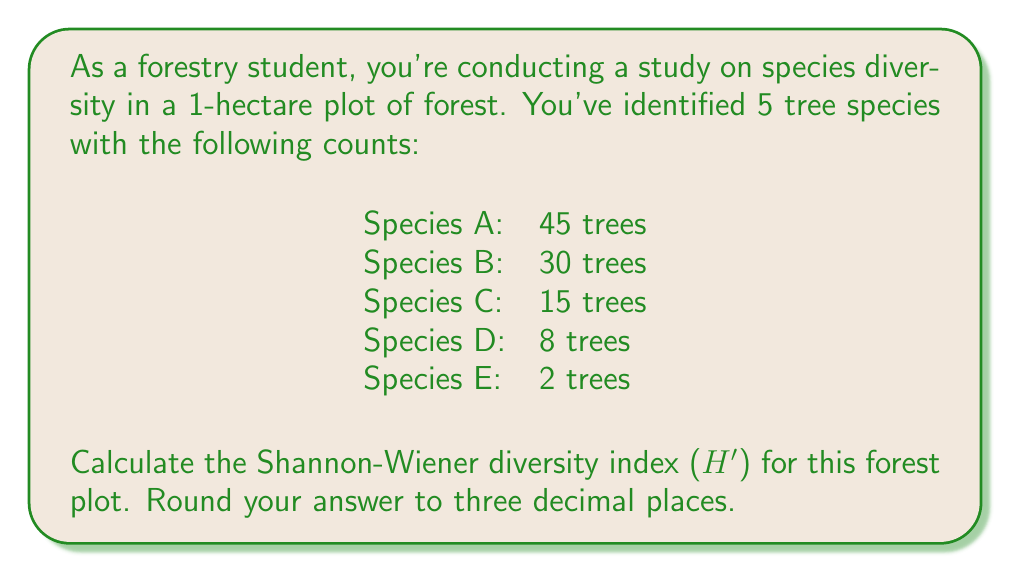Give your solution to this math problem. The Shannon-Wiener diversity index (H') is calculated using the formula:

$$ H' = -\sum_{i=1}^{R} p_i \ln(p_i) $$

Where:
- $R$ is the number of species
- $p_i$ is the proportion of individuals belonging to the $i$-th species

Step 1: Calculate the total number of trees.
Total trees = 45 + 30 + 15 + 8 + 2 = 100

Step 2: Calculate the proportion ($p_i$) for each species.
$p_A = 45/100 = 0.45$
$p_B = 30/100 = 0.30$
$p_C = 15/100 = 0.15$
$p_D = 8/100 = 0.08$
$p_E = 2/100 = 0.02$

Step 3: Calculate $p_i \ln(p_i)$ for each species.
Species A: $0.45 \ln(0.45) = -0.3567$
Species B: $0.30 \ln(0.30) = -0.3611$
Species C: $0.15 \ln(0.15) = -0.2849$
Species D: $0.08 \ln(0.08) = -0.2021$
Species E: $0.02 \ln(0.02) = -0.0780$

Step 4: Sum the negative values of $p_i \ln(p_i)$ to get H'.
$H' = -(-0.3567 + -0.3611 + -0.2849 + -0.2021 + -0.0780)$
$H' = 1.2828$

Step 5: Round to three decimal places.
$H' = 1.283$
Answer: The Shannon-Wiener diversity index (H') for this forest plot is 1.283. 